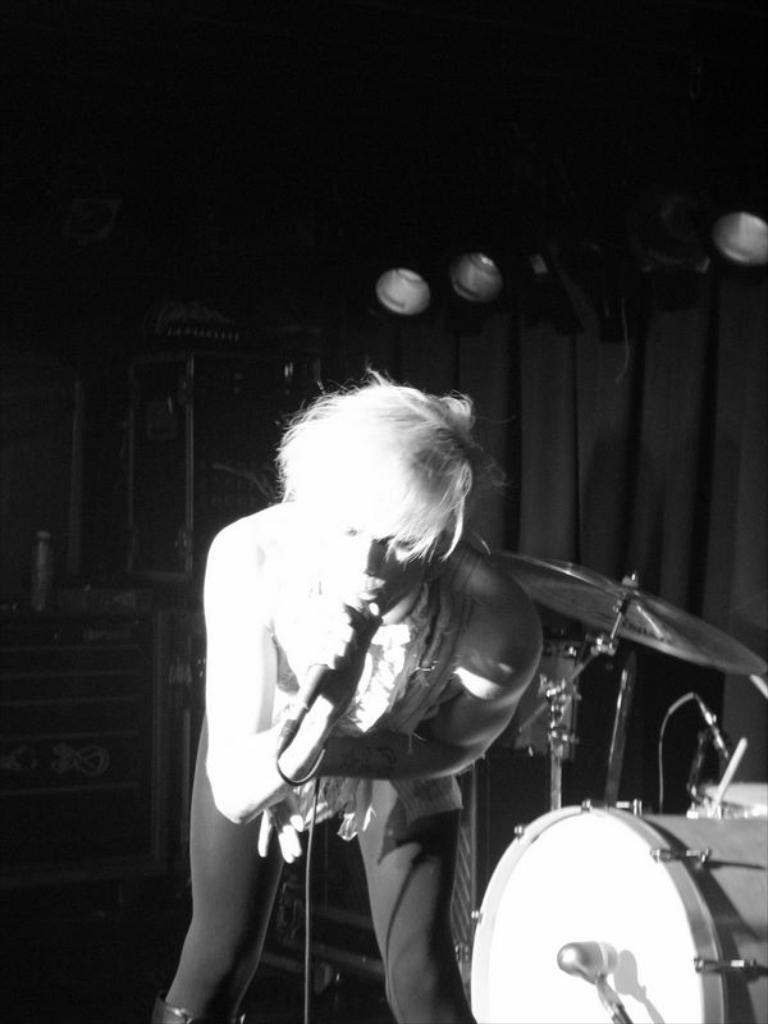What is the person in the image holding? The person is holding a microphone in the image. What else can be seen in the image besides the person with the microphone? There is a musical instrument in the image. How would you describe the lighting in the image? The background of the image is dark, but there are lights in the background. What can be seen in the background of the image? There is a curtain and other objects in the background of the image. How much does the cracker cost in the image? There is no cracker present in the image, so it is not possible to determine its cost. 